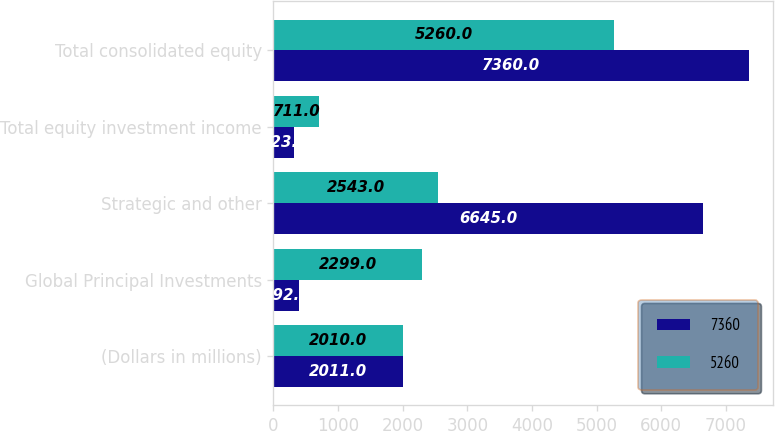<chart> <loc_0><loc_0><loc_500><loc_500><stacked_bar_chart><ecel><fcel>(Dollars in millions)<fcel>Global Principal Investments<fcel>Strategic and other<fcel>Total equity investment income<fcel>Total consolidated equity<nl><fcel>7360<fcel>2011<fcel>392<fcel>6645<fcel>323<fcel>7360<nl><fcel>5260<fcel>2010<fcel>2299<fcel>2543<fcel>711<fcel>5260<nl></chart> 